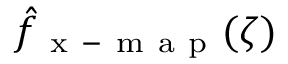<formula> <loc_0><loc_0><loc_500><loc_500>\hat { f } _ { x - m a p } ( \zeta )</formula> 